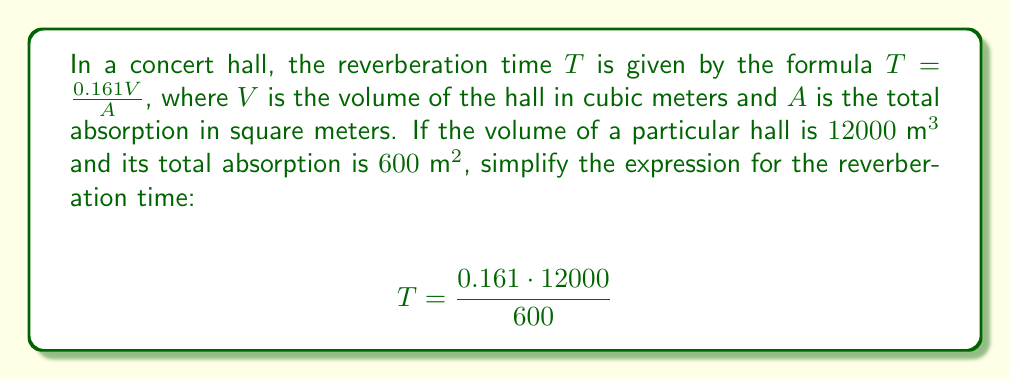Show me your answer to this math problem. Let's simplify this expression step by step:

1) First, let's multiply the numerator:
   $$T = \frac{1932}{600}$$

2) Now, we can simplify this fraction by dividing both the numerator and denominator by their greatest common divisor (GCD).
   The GCD of 1932 and 600 is 12.

3) Dividing both numbers by 12:
   $$T = \frac{1932 \div 12}{600 \div 12} = \frac{161}{50}$$

4) This fraction cannot be simplified further, so this is our final answer.

The reverberation time is therefore $\frac{161}{50}$ seconds, or 3.22 seconds when converted to a decimal.
Answer: $\frac{161}{50}$ seconds 